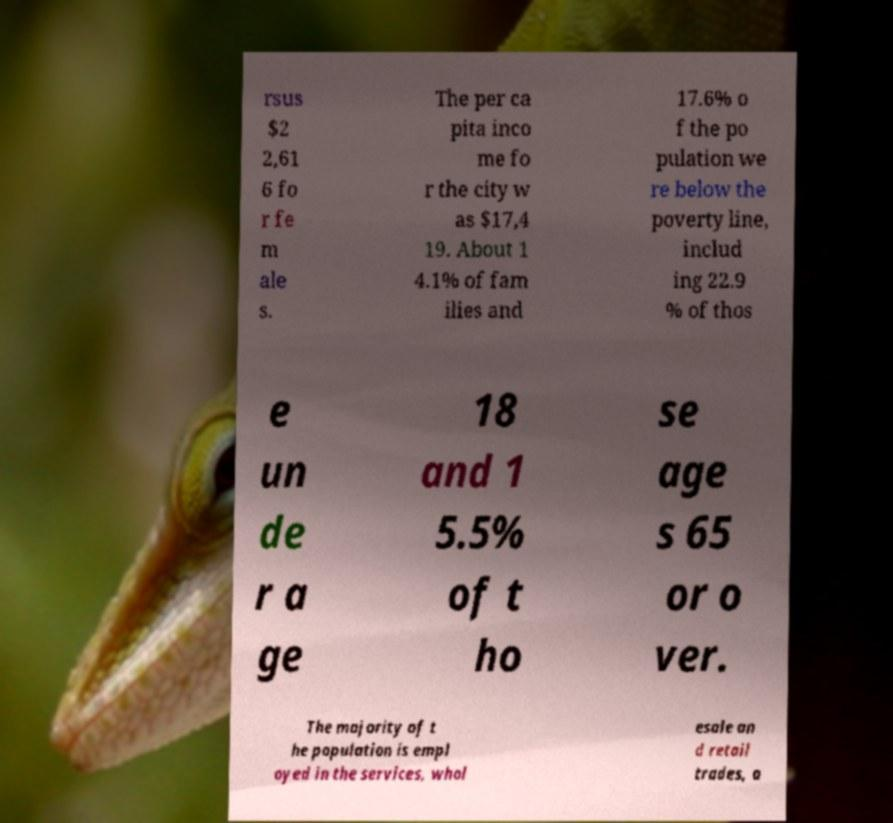For documentation purposes, I need the text within this image transcribed. Could you provide that? rsus $2 2,61 6 fo r fe m ale s. The per ca pita inco me fo r the city w as $17,4 19. About 1 4.1% of fam ilies and 17.6% o f the po pulation we re below the poverty line, includ ing 22.9 % of thos e un de r a ge 18 and 1 5.5% of t ho se age s 65 or o ver. The majority of t he population is empl oyed in the services, whol esale an d retail trades, a 